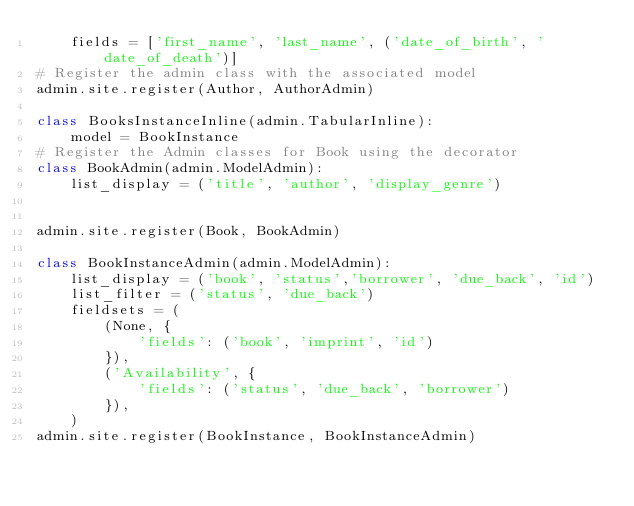Convert code to text. <code><loc_0><loc_0><loc_500><loc_500><_Python_>    fields = ['first_name', 'last_name', ('date_of_birth', 'date_of_death')]
# Register the admin class with the associated model
admin.site.register(Author, AuthorAdmin)

class BooksInstanceInline(admin.TabularInline):
    model = BookInstance
# Register the Admin classes for Book using the decorator
class BookAdmin(admin.ModelAdmin):
    list_display = ('title', 'author', 'display_genre')
    

admin.site.register(Book, BookAdmin)

class BookInstanceAdmin(admin.ModelAdmin):
    list_display = ('book', 'status','borrower', 'due_back', 'id')
    list_filter = ('status', 'due_back')
    fieldsets = (
        (None, {
            'fields': ('book', 'imprint', 'id')
        }),
        ('Availability', {
            'fields': ('status', 'due_back', 'borrower')
        }),
    )
admin.site.register(BookInstance, BookInstanceAdmin)

</code> 